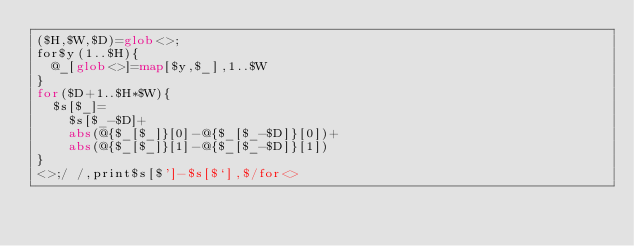Convert code to text. <code><loc_0><loc_0><loc_500><loc_500><_Perl_>($H,$W,$D)=glob<>;
for$y(1..$H){
	@_[glob<>]=map[$y,$_],1..$W
}
for($D+1..$H*$W){
	$s[$_]=
		$s[$_-$D]+
		abs(@{$_[$_]}[0]-@{$_[$_-$D]}[0])+
		abs(@{$_[$_]}[1]-@{$_[$_-$D]}[1])
}
<>;/ /,print$s[$']-$s[$`],$/for<>
</code> 